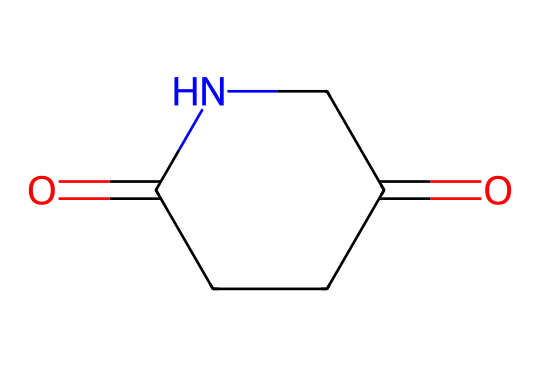What is the molecular formula of glutarimide? To determine the molecular formula, we count the number of each type of atom in the structure. In the provided SMILES, we see that there are five carbon (C) atoms, seven hydrogen (H) atoms, two nitrogen (N) atoms, and two oxygen (O) atoms. Thus, the molecular formula is C5H7N2O2.
Answer: C5H7N2O2 How many rings are present in glutarimide? A careful examination of the structure shows that there is one cyclic part in glutarimide, which consists of a nitrogen atom and adjacent carbon atoms forming a cyclic structure. Therefore, there is one ring.
Answer: one What type of functional groups are present in glutarimide? Analyzing the structure, we identify two types of functional groups: an imide group (C=O and N, typical for imides) and a carbonyl group (C=O), which is part of the imide function and indicates the presence of amides.
Answer: imide and carbonyl What is the hybridization of the nitrogen atom in glutarimide? The nitrogen atom in the glutarimide structure is bonded to one carbon atom and one hydrogen atom along with a carbon atom where it contributes to the cyclic structure. The presence of three regions of electron density around the nitrogen indicates it is sp2 hybridized.
Answer: sp2 Which part of glutarimide contributes to its pharmacological properties? The imide functional group is significant for the pharmacological activity of glutarimide, as it interacts with biological targets in the body and is often involved in anticonvulsant activity. It is the specific arrangement of the imide that provides the desired characteristics.
Answer: imide functional group What type of isomerism is possible for glutarimide? Considering the structural flexibility and electron reconfiguration around the imide functional group and the presence of the carbonyl functionalities, glutarimide can exhibit both geometric isomerism (cis/trans) due to its rigid cyclic structure and structural isomerism with possible variations in the arrangement of atoms.
Answer: geometric and structural 